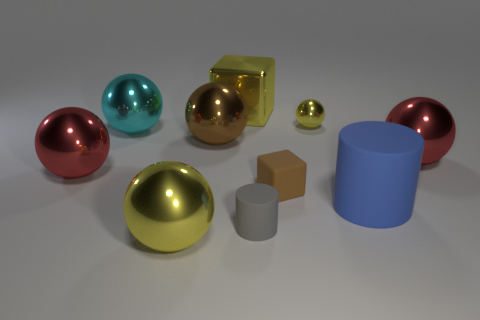Subtract all cyan balls. How many balls are left? 5 Subtract all cyan balls. How many balls are left? 5 Subtract all cubes. How many objects are left? 8 Subtract 2 balls. How many balls are left? 4 Subtract all cyan spheres. Subtract all purple cylinders. How many spheres are left? 5 Subtract all yellow spheres. How many yellow blocks are left? 1 Subtract all matte objects. Subtract all big cyan shiny things. How many objects are left? 6 Add 2 tiny yellow spheres. How many tiny yellow spheres are left? 3 Add 3 big blue objects. How many big blue objects exist? 4 Subtract 1 yellow spheres. How many objects are left? 9 